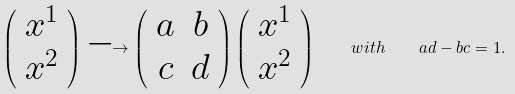<formula> <loc_0><loc_0><loc_500><loc_500>\left ( \begin{array} { c } x ^ { 1 } \\ x ^ { 2 } \end{array} \right ) \longrightarrow \left ( \begin{array} { c c } a & b \\ c & d \end{array} \right ) \left ( \begin{array} { c } x ^ { 1 } \\ x ^ { 2 } \end{array} \right ) \quad w i t h \quad a d - b c = 1 .</formula> 